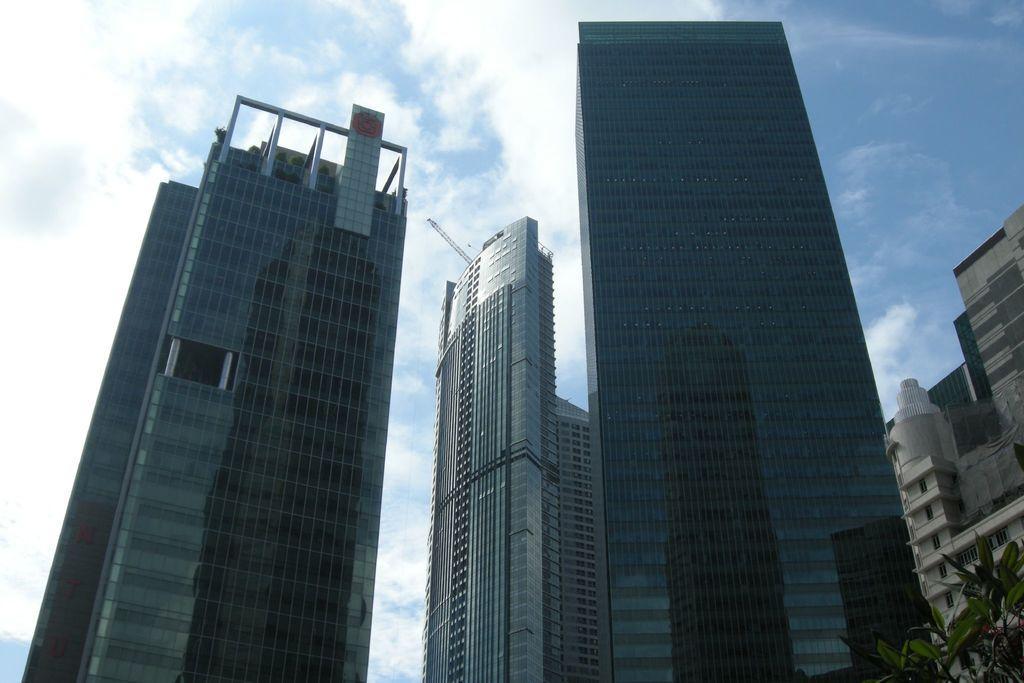How would you summarize this image in a sentence or two? In this image we can see tower buildings, plant and the blue color sky with clouds in the background. 